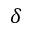Convert formula to latex. <formula><loc_0><loc_0><loc_500><loc_500>\delta</formula> 